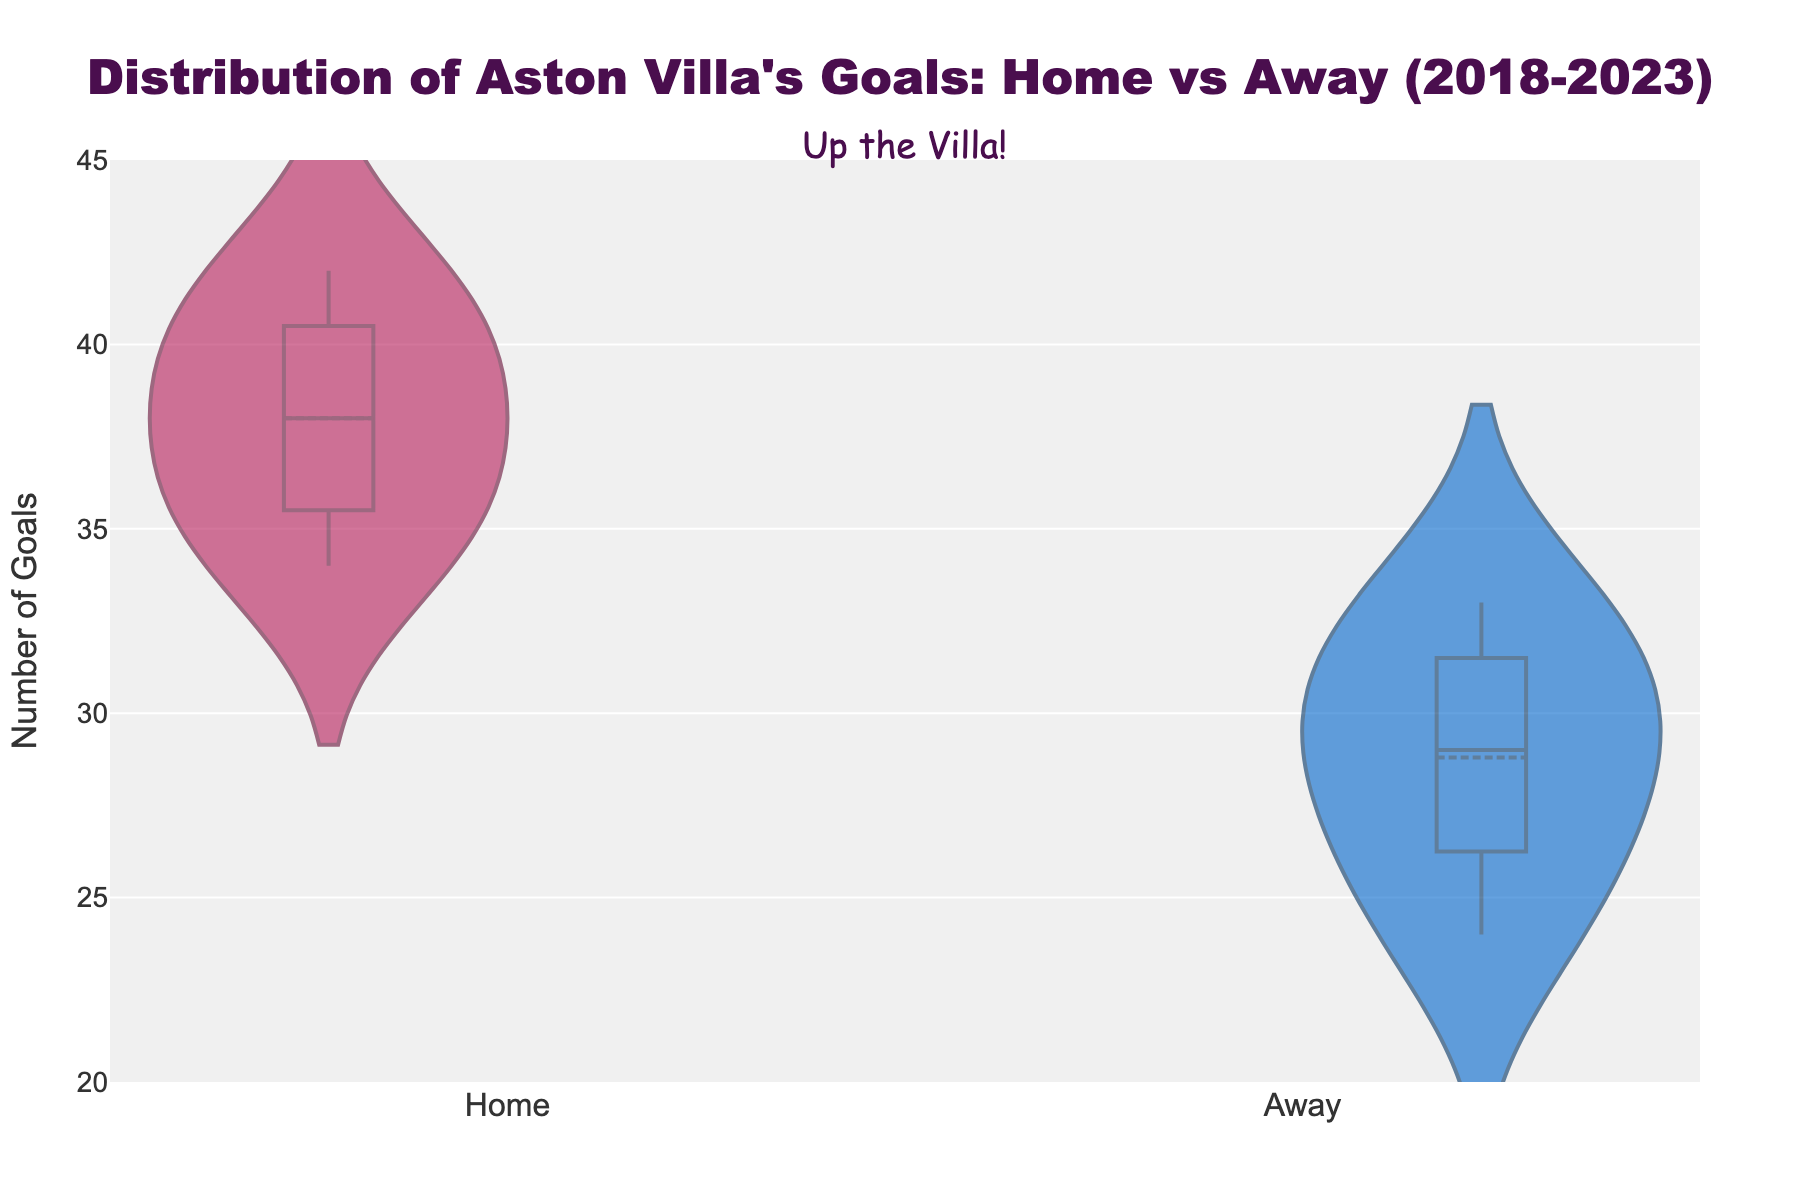How many goals did Aston Villa score at home in the 2020-2021 season? The plot shows individual data points for goals scored at home and away. Locate the point representing the 2020-2021 home goals and read the value.
Answer: 40 What is the average number of goals scored by Aston Villa in away matches over the five seasons? Add up the goals scored in away matches (27, 24, 29, 31, 33) and divide by the number of seasons (5).
Answer: 28.8 Which type of match tends to have higher goal counts, home or away? Compare the distributions of goals in home and away matches; the home distribution generally has higher values.
Answer: Home What's the difference between the highest and lowest number of goals scored at home? Identify the highest (42 goals in 2022-2023) and lowest (34 goals in 2018-2019) values from the home goals data, then subtract the smaller value from the larger one.
Answer: 8 In which season did Aston Villa score a similar number of goals both home and away? Compare the home and away goals for each season, identifying the closest values. 36 home vs. 31 away in 2021-2022 are closest.
Answer: 2021-2022 What is the range of goals scored in away matches? Identify the highest (33 goals) and lowest (24 goals) values from the away goals data, then subtract the smaller value from the larger one.
Answer: 9 How does the median number of goals scored at home compare to that of away matches? The plot shows the median line for both home and away distributions. Identify and compare their positions on the y-axis.
Answer: Higher at home What season had the highest number of goals scored in an away match? Look at the data points for away goals across the seasons to find the highest value, which is 33 away goals in 2022-2023.
Answer: 2022-2023 Do home matches show more variability in goals scored compared to away matches? Observe the spread of data points (interquartile range) in both home and away distributions; home matches have a slightly wider spread.
Answer: Yes What is the interquartile range (IQR) for goals scored at home? The IQR is the difference between the upper quartile (Q3) and lower quartile (Q1) of the home goals data. Observe where these quartiles are on the y-axis from the box plot within the violin plot.
Answer: Around 38 - 34 = 6 